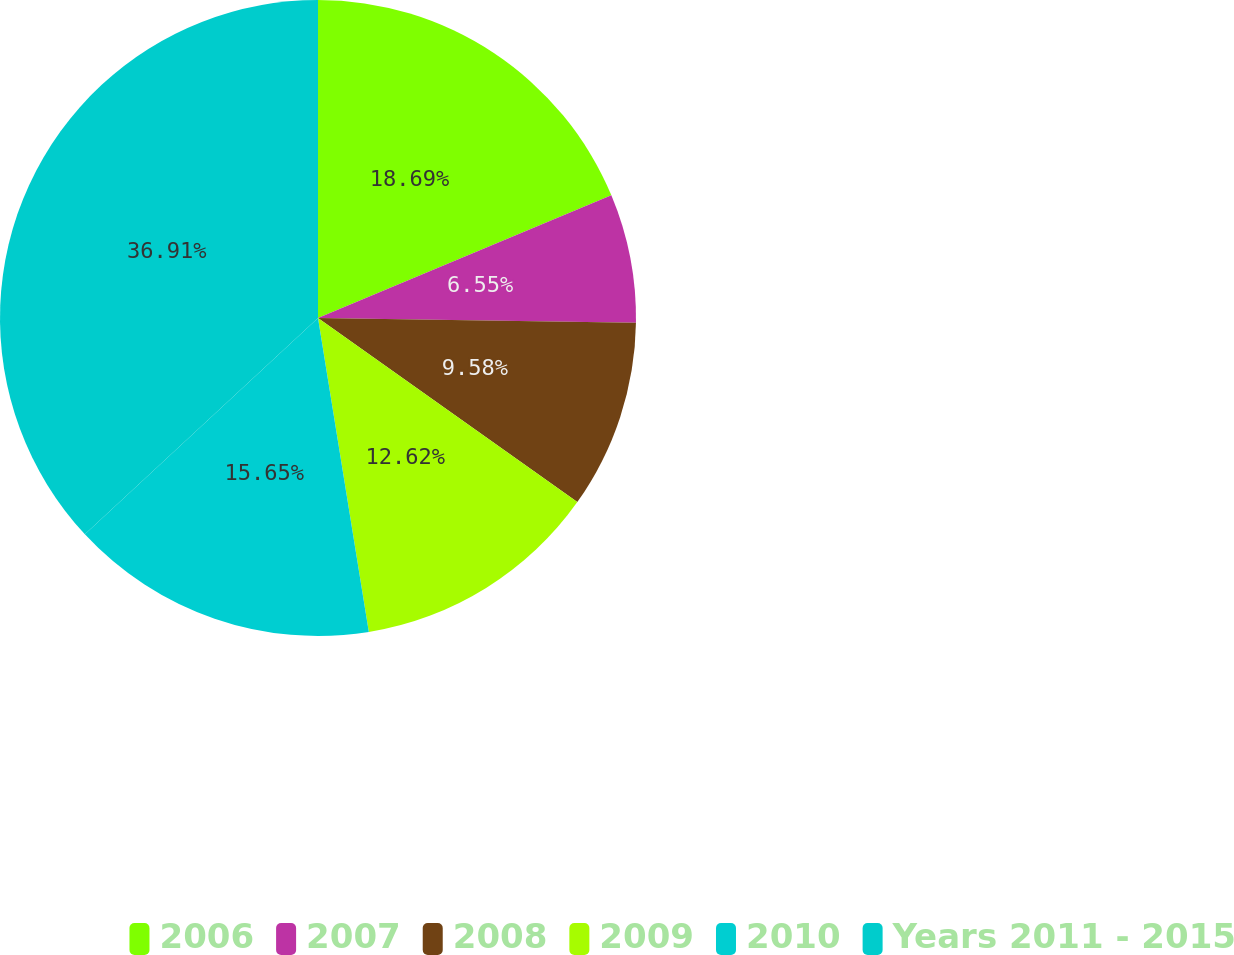Convert chart to OTSL. <chart><loc_0><loc_0><loc_500><loc_500><pie_chart><fcel>2006<fcel>2007<fcel>2008<fcel>2009<fcel>2010<fcel>Years 2011 - 2015<nl><fcel>18.69%<fcel>6.55%<fcel>9.58%<fcel>12.62%<fcel>15.65%<fcel>36.9%<nl></chart> 